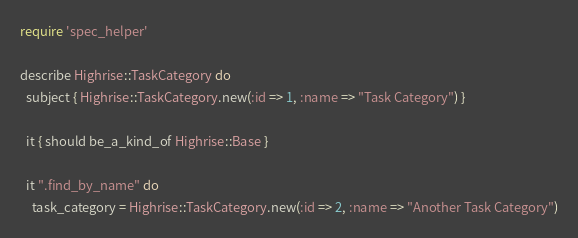<code> <loc_0><loc_0><loc_500><loc_500><_Ruby_>require 'spec_helper'

describe Highrise::TaskCategory do
  subject { Highrise::TaskCategory.new(:id => 1, :name => "Task Category") }
  
  it { should be_a_kind_of Highrise::Base }
  
  it ".find_by_name" do
    task_category = Highrise::TaskCategory.new(:id => 2, :name => "Another Task Category")</code> 